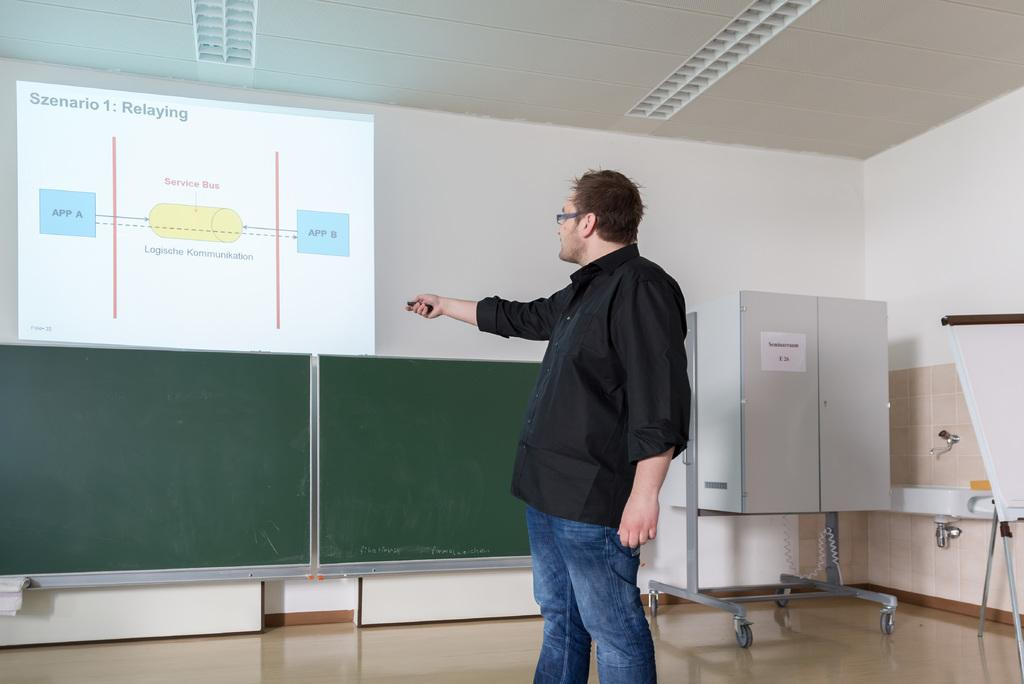<image>
Render a clear and concise summary of the photo. A man points to a whiteboard which has App A written on it. 